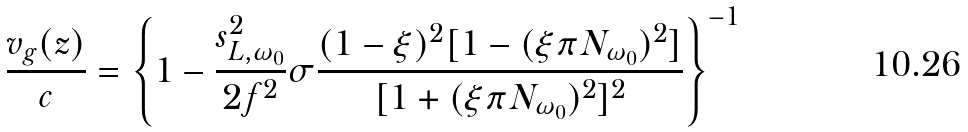<formula> <loc_0><loc_0><loc_500><loc_500>\frac { v _ { g } ( z ) } { c } = \left \{ 1 - \frac { s _ { L , \omega _ { 0 } } ^ { 2 } } { 2 f ^ { 2 } } \sigma \frac { ( 1 - \xi ) ^ { 2 } [ 1 - ( \xi \pi N _ { \omega _ { 0 } } ) ^ { 2 } ] } { [ 1 + ( \xi \pi N _ { \omega _ { 0 } } ) ^ { 2 } ] ^ { 2 } } \right \} ^ { - 1 }</formula> 